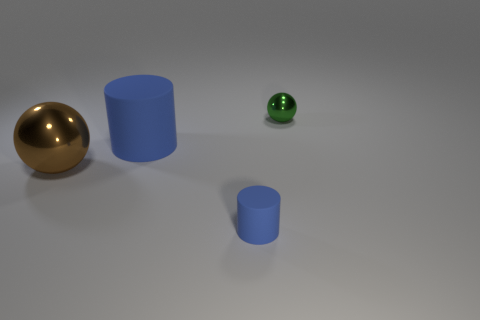What number of other cylinders are the same color as the tiny rubber cylinder? There is one other cylinder that shares the same blue color as the small rubber cylinder. 